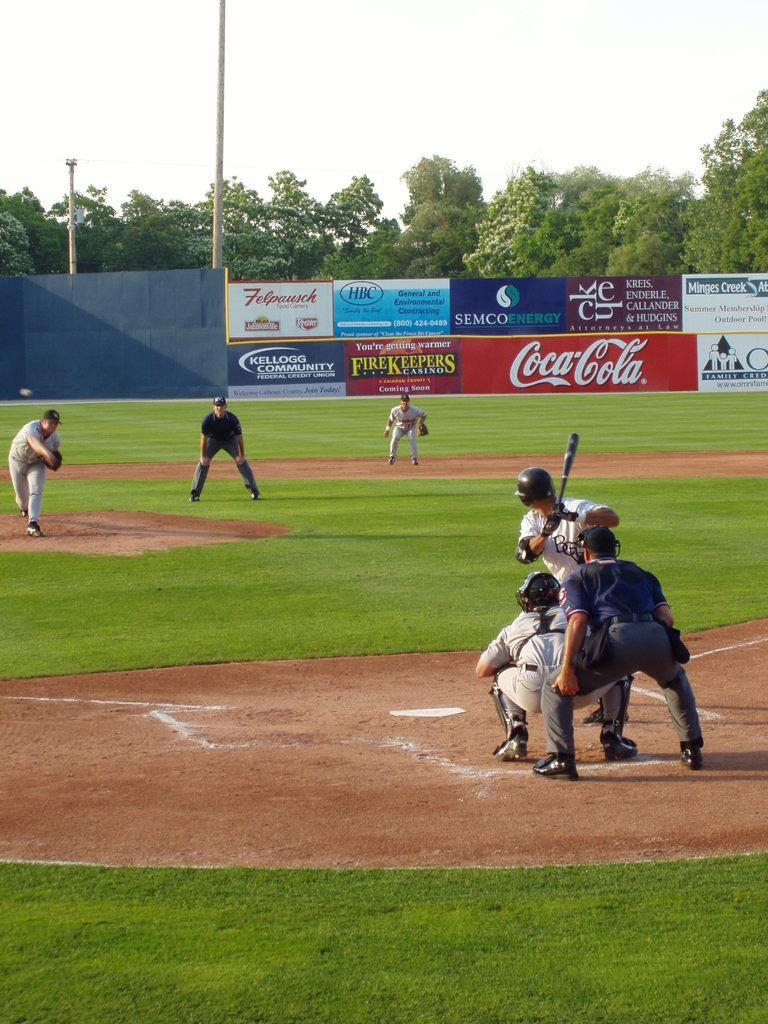What are the people in the image doing? The persons standing on the ground are likely engaged in some activity or standing still. What can be seen in the background of the image? In the background, there are advertisement boards, poles, trees, and the sky. Can you describe the environment in the image? The environment in the image includes people standing on the ground and various objects and features in the background, such as advertisement boards, poles, trees, and the sky. What type of yak can be seen carrying a tray in the image? There is no yak or tray present in the image. How many times does the person smash the pole in the image? There is no indication of anyone smashing a pole in the image. 